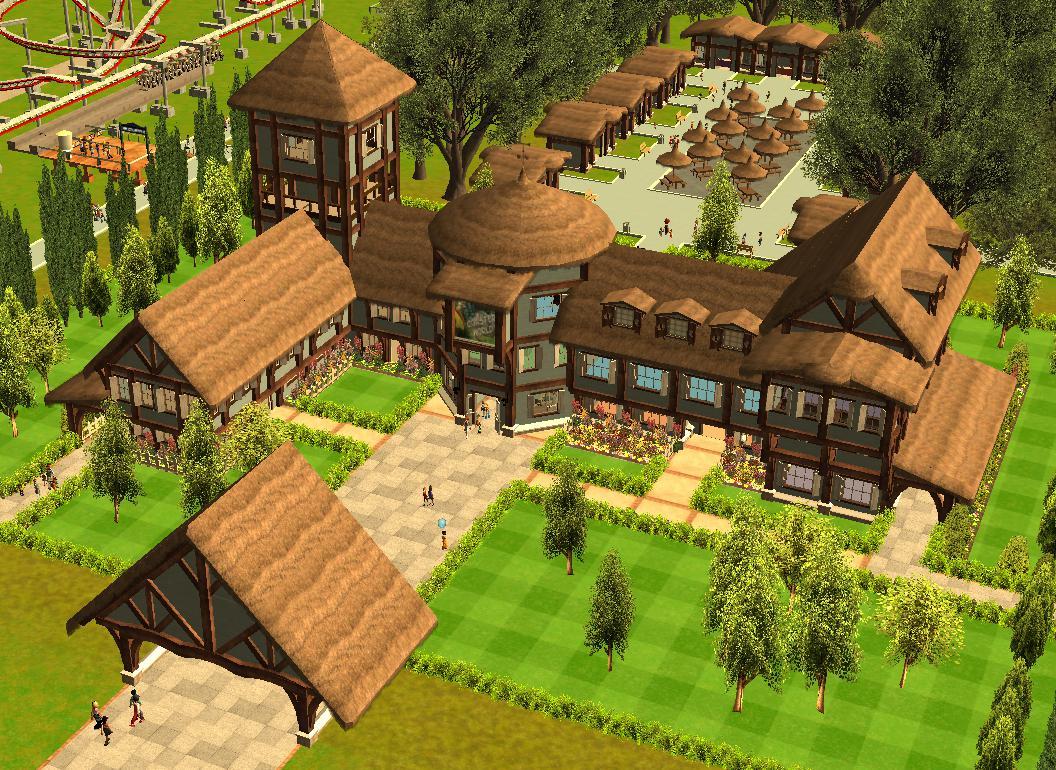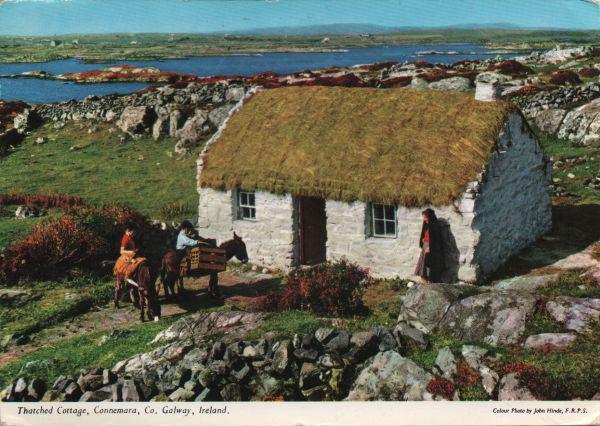The first image is the image on the left, the second image is the image on the right. For the images shown, is this caption "The right image features a building with a roof featuring an inverted cone-shape with gray Xs on it, over arch windows that are above an arch door." true? Answer yes or no. No. The first image is the image on the left, the second image is the image on the right. Evaluate the accuracy of this statement regarding the images: "The left and right image contains a total of two home.". Is it true? Answer yes or no. No. 